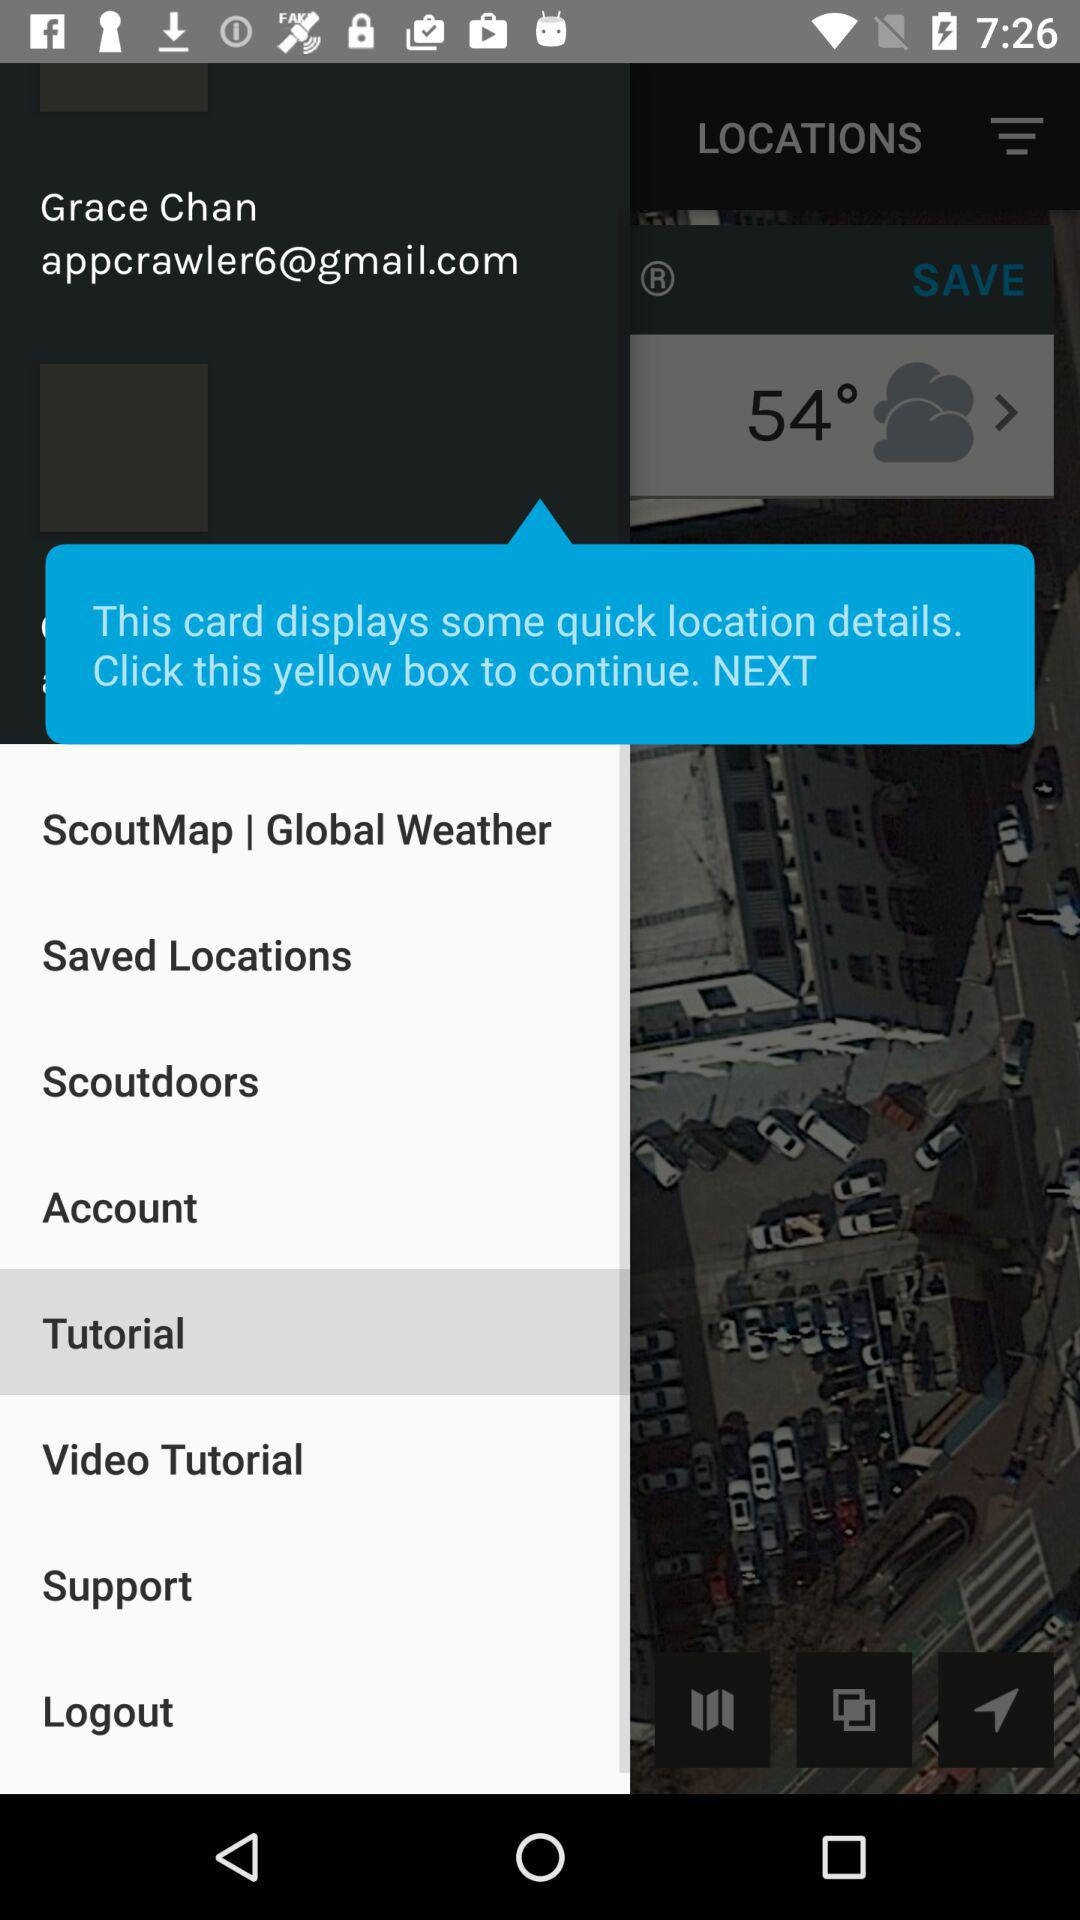What is the email address? The email address is appcrawler6@gmail.com. 